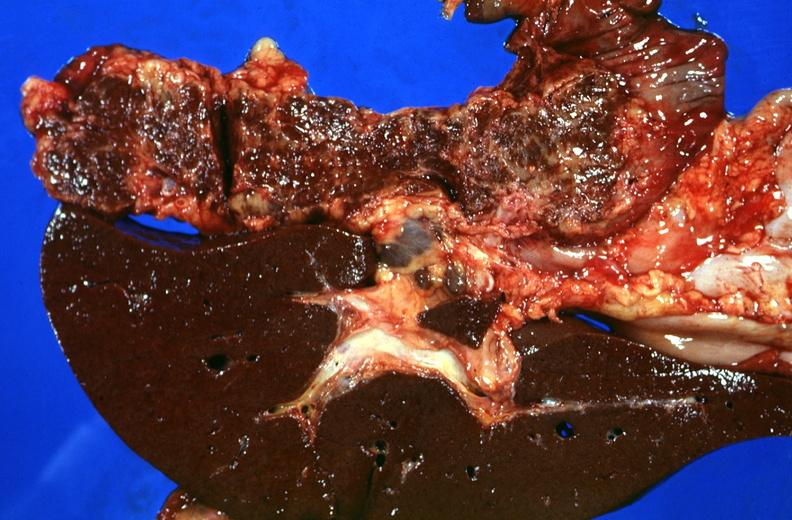s hepatobiliary present?
Answer the question using a single word or phrase. Yes 